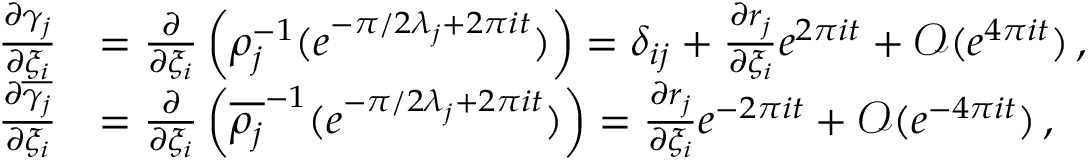<formula> <loc_0><loc_0><loc_500><loc_500>\begin{array} { r l } { { \frac { \partial \gamma _ { j } } { \partial \xi _ { i } } } } & { = { \frac { \partial } { \partial \xi _ { i } } } \left ( \rho _ { j } ^ { - 1 } ( e ^ { - \pi / 2 \lambda _ { j } + 2 \pi i t } ) \right ) = \delta _ { i j } + { \frac { \partial r _ { j } } { \partial \xi _ { i } } } e ^ { 2 \pi i t } + \mathcal { O } ( e ^ { 4 \pi i t } ) \, , } \\ { { \frac { \partial \overline { { \gamma _ { j } } } } { \partial \xi _ { i } } } } & { = { \frac { \partial } { \partial \xi _ { i } } } \left ( \overline { { \rho _ { j } } } ^ { - 1 } ( e ^ { - \pi / 2 \lambda _ { j } + 2 \pi i t } ) \right ) = { \frac { \partial r _ { j } } { \partial \xi _ { i } } } e ^ { - 2 \pi i t } + \mathcal { O } ( e ^ { - 4 \pi i t } ) \, , } \end{array}</formula> 